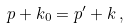Convert formula to latex. <formula><loc_0><loc_0><loc_500><loc_500>p + k _ { 0 } = p ^ { \prime } + k \, ,</formula> 